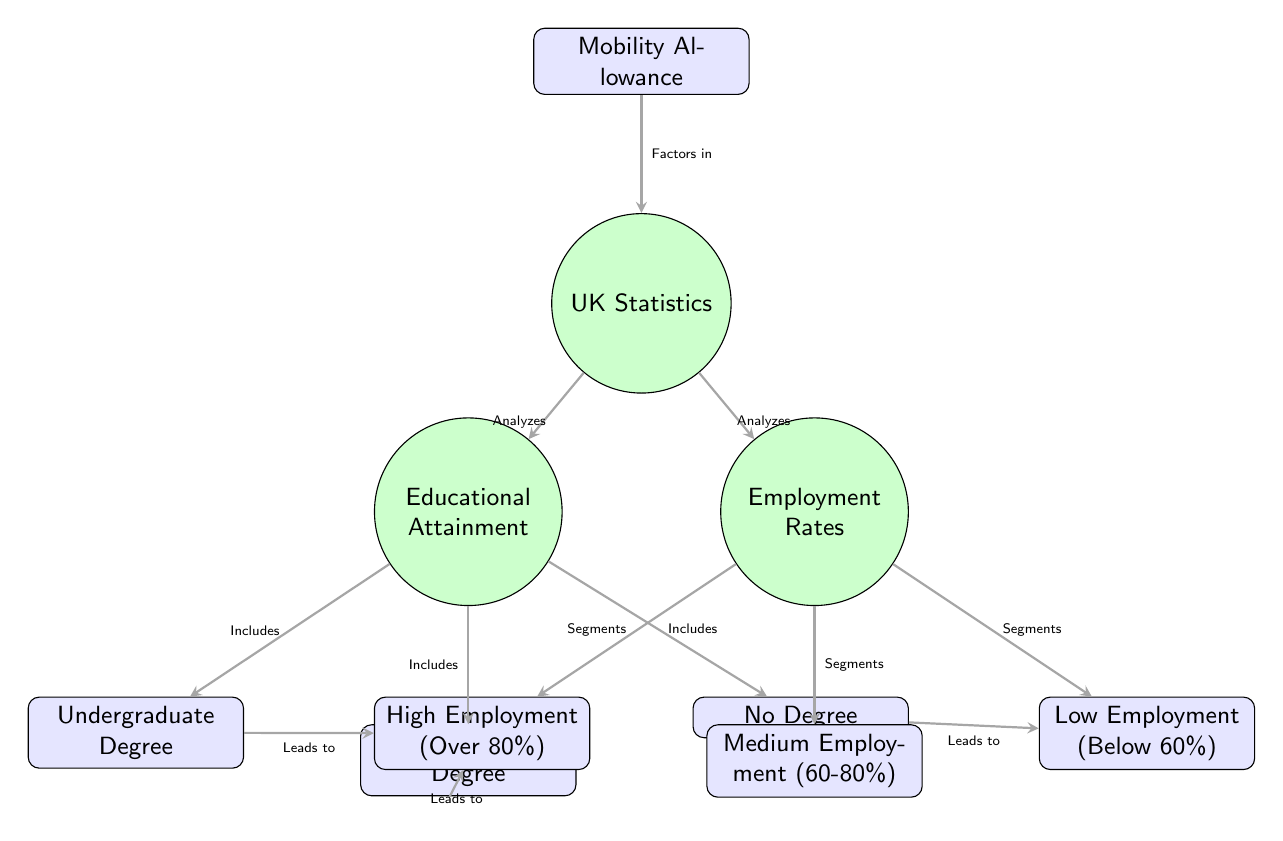What are the three categories of Educational Attainment? The diagram lists three sub-nodes under Educational Attainment: Undergraduate Degree, Postgraduate Degree, and No Degree.
Answer: Undergraduate Degree, Postgraduate Degree, No Degree What segments are associated with Employment Rates? The Employment Rates node has three segments below it: High Employment, Medium Employment, and Low Employment, indicating different employment level categories.
Answer: High Employment, Medium Employment, Low Employment What is the relationship between Undergraduate Degree and High Employment? The arrow from the Undergraduate Degree node to the High Employment node indicates a direct connection with the label "Leads to," suggesting that having an undergraduate degree leads to high employment rates.
Answer: Leads to How many nodes are there in the diagram? By counting all the main nodes and their sub-nodes, we find that there are a total of 8 nodes in the diagram: 1 for Educational Attainment, 1 for Employment Rates, 1 for UK Statistics, 1 for Mobility Allowance, and 3 sub-nodes for Educational Attainment and 3 sub-nodes for Employment Rates. This gives us 1 + 1 + 1 + 1 + 3 + 3 = 10.
Answer: 10 Which factor is considered in the UK Statistics node? The arrow from the Mobility Allowance node to the UK Statistics node indicates that the Mobility Allowance is a factor considered when analyzing UK statistics in relation to educational attainment and employment rates.
Answer: Factors in 